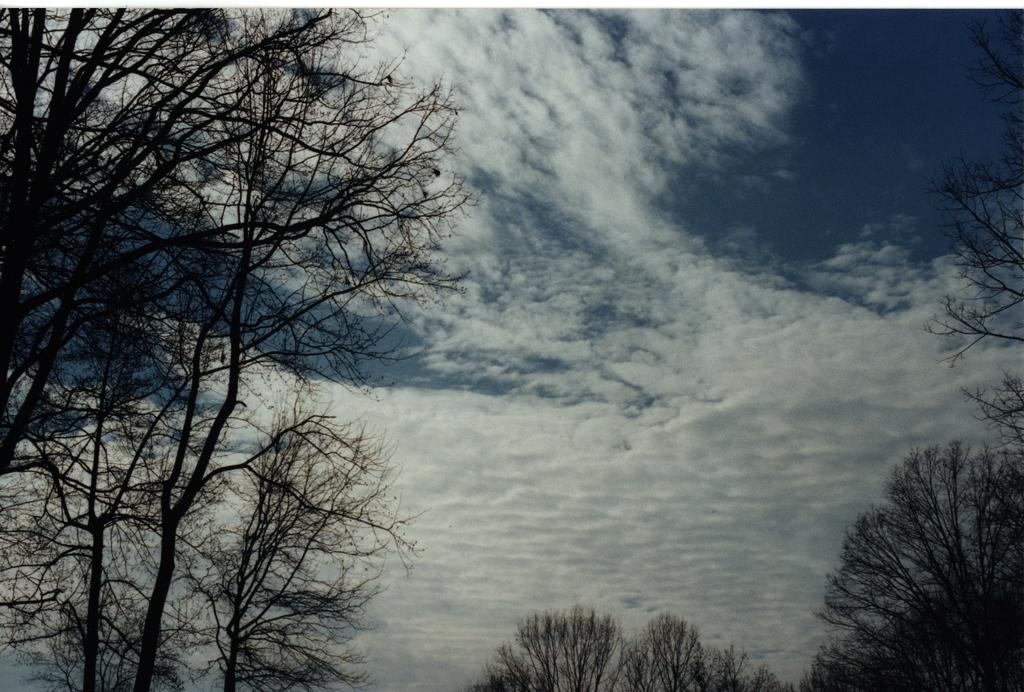What is located in the foreground of the image? There are trees in the foreground of the image. What can be seen in the background of the image? The sky is visible in the image. What is present in the sky? There are clouds in the sky. What type of team is responsible for the destruction and pollution in the image? There is no indication of destruction or pollution in the image, nor is there any reference to a team. 